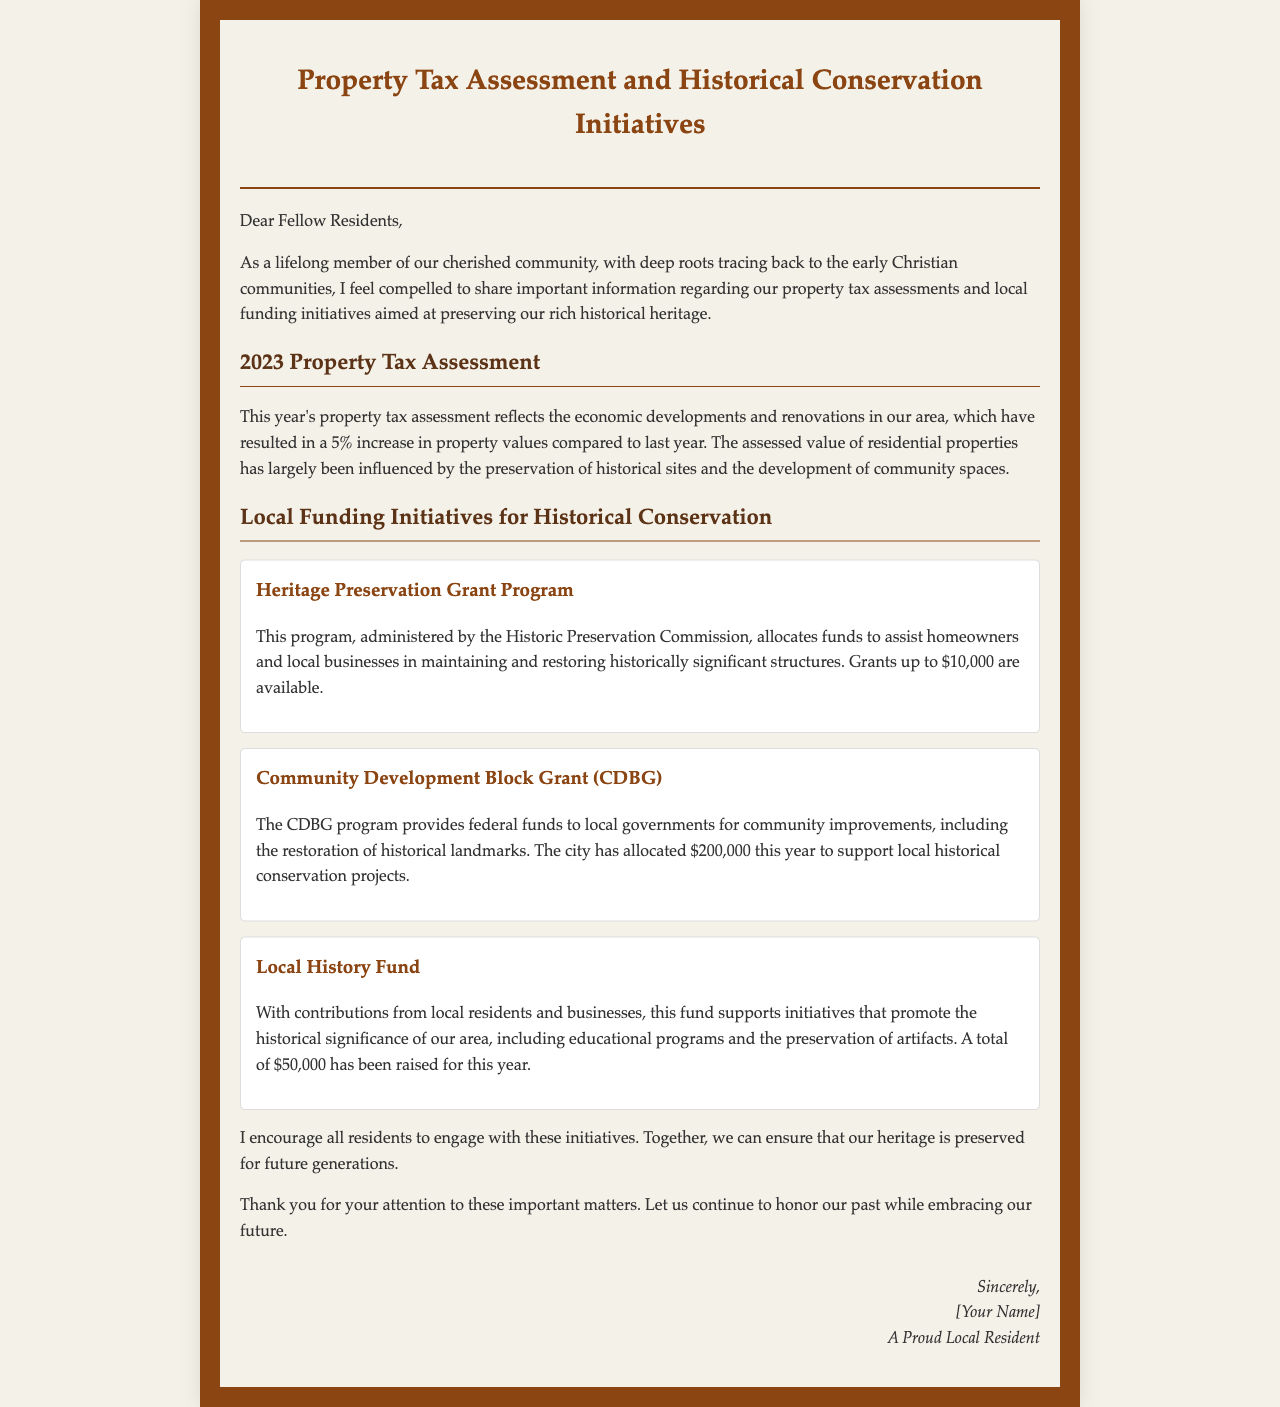What is the percentage increase in property values this year? The document states that there is a 5% increase in property values compared to last year.
Answer: 5% What is the maximum grant amount available through the Heritage Preservation Grant Program? The document mentions that grants up to $10,000 are available through this program.
Answer: $10,000 How much federal funding has been allocated for local historical conservation projects this year? The document specifies that the city has allocated $200,000 this year from the CDBG program for local historical conservation projects.
Answer: $200,000 What is the total amount raised for the Local History Fund this year? The document indicates that a total of $50,000 has been raised for the Local History Fund this year.
Answer: $50,000 Who administers the Heritage Preservation Grant Program? The document states that the Heritage Preservation Grant Program is administered by the Historic Preservation Commission.
Answer: Historic Preservation Commission What is the purpose of the Community Development Block Grant (CDBG) program? The document explains that the CDBG program provides funds for community improvements, including the restoration of historical landmarks.
Answer: Community improvements How does the author feel about their community's historical heritage? The author expresses a deep connection to the community and a commitment to preserving its historical heritage.
Answer: Strongly committed What is the document's overall theme? The letter addresses property tax assessments and local funding initiatives for historical conservation in the community.
Answer: Property tax and historical conservation What does the author encourage residents to do? The author encourages residents to engage with local funding initiatives for historical conservation.
Answer: Engage with initiatives 